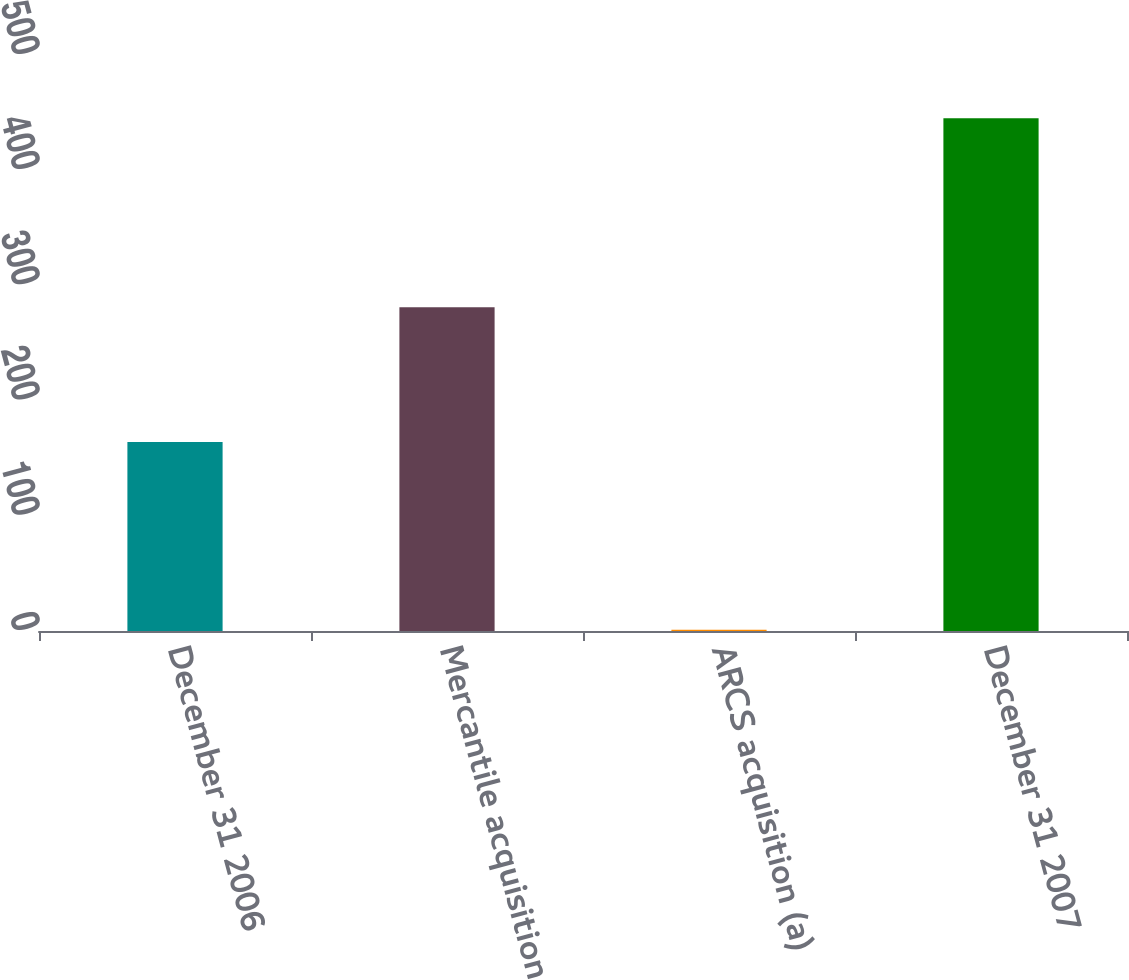<chart> <loc_0><loc_0><loc_500><loc_500><bar_chart><fcel>December 31 2006<fcel>Mercantile acquisition<fcel>ARCS acquisition (a)<fcel>December 31 2007<nl><fcel>164<fcel>281<fcel>1<fcel>445<nl></chart> 